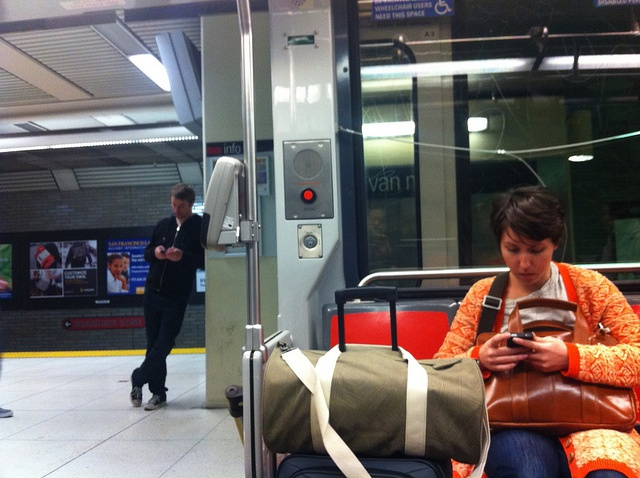Describe the objects in this image and their specific colors. I can see people in darkgray, black, orange, maroon, and red tones, handbag in darkgray, black, ivory, and tan tones, handbag in darkgray, maroon, black, and brown tones, people in darkgray, black, gray, and maroon tones, and suitcase in darkgray, black, and gray tones in this image. 